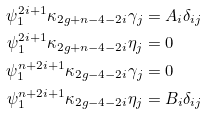Convert formula to latex. <formula><loc_0><loc_0><loc_500><loc_500>\psi _ { 1 } ^ { 2 i + 1 } \kappa _ { 2 g + n - 4 - 2 i } \gamma _ { j } & = A _ { i } \delta _ { i j } \\ \psi _ { 1 } ^ { 2 i + 1 } \kappa _ { 2 g + n - 4 - 2 i } \eta _ { j } & = 0 \\ \psi _ { 1 } ^ { n + 2 i + 1 } \kappa _ { 2 g - 4 - 2 i } \gamma _ { j } & = 0 \\ \psi _ { 1 } ^ { n + 2 i + 1 } \kappa _ { 2 g - 4 - 2 i } \eta _ { j } & = B _ { i } \delta _ { i j }</formula> 